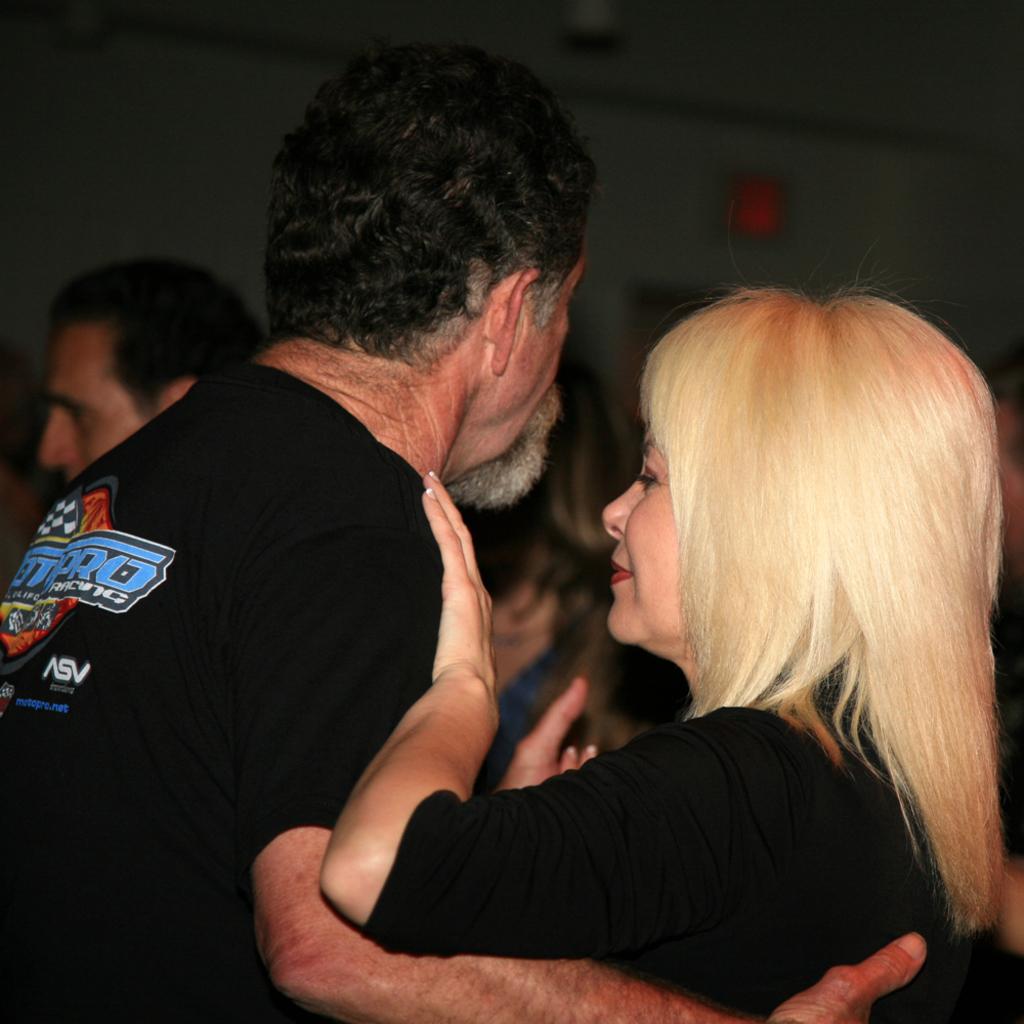What sport is the gentlemans t-shirt for?
Offer a terse response. Racing. 